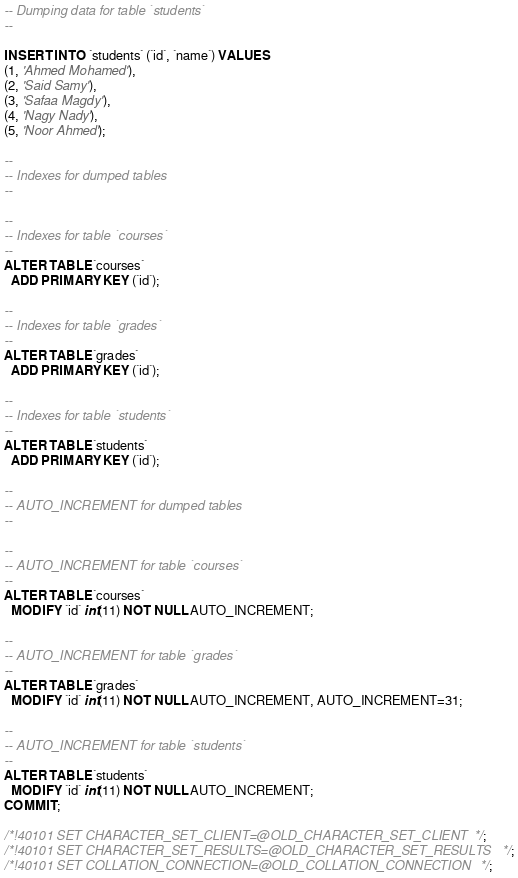Convert code to text. <code><loc_0><loc_0><loc_500><loc_500><_SQL_>-- Dumping data for table `students`
--

INSERT INTO `students` (`id`, `name`) VALUES
(1, 'Ahmed Mohamed'),
(2, 'Said Samy'),
(3, 'Safaa Magdy'),
(4, 'Nagy Nady'),
(5, 'Noor Ahmed');

--
-- Indexes for dumped tables
--

--
-- Indexes for table `courses`
--
ALTER TABLE `courses`
  ADD PRIMARY KEY (`id`);

--
-- Indexes for table `grades`
--
ALTER TABLE `grades`
  ADD PRIMARY KEY (`id`);

--
-- Indexes for table `students`
--
ALTER TABLE `students`
  ADD PRIMARY KEY (`id`);

--
-- AUTO_INCREMENT for dumped tables
--

--
-- AUTO_INCREMENT for table `courses`
--
ALTER TABLE `courses`
  MODIFY `id` int(11) NOT NULL AUTO_INCREMENT;

--
-- AUTO_INCREMENT for table `grades`
--
ALTER TABLE `grades`
  MODIFY `id` int(11) NOT NULL AUTO_INCREMENT, AUTO_INCREMENT=31;

--
-- AUTO_INCREMENT for table `students`
--
ALTER TABLE `students`
  MODIFY `id` int(11) NOT NULL AUTO_INCREMENT;
COMMIT;

/*!40101 SET CHARACTER_SET_CLIENT=@OLD_CHARACTER_SET_CLIENT */;
/*!40101 SET CHARACTER_SET_RESULTS=@OLD_CHARACTER_SET_RESULTS */;
/*!40101 SET COLLATION_CONNECTION=@OLD_COLLATION_CONNECTION */;
</code> 